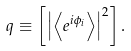<formula> <loc_0><loc_0><loc_500><loc_500>q \equiv \left [ \left | \left \langle e ^ { i \phi _ { i } } \right \rangle \right | ^ { 2 } \right ] .</formula> 